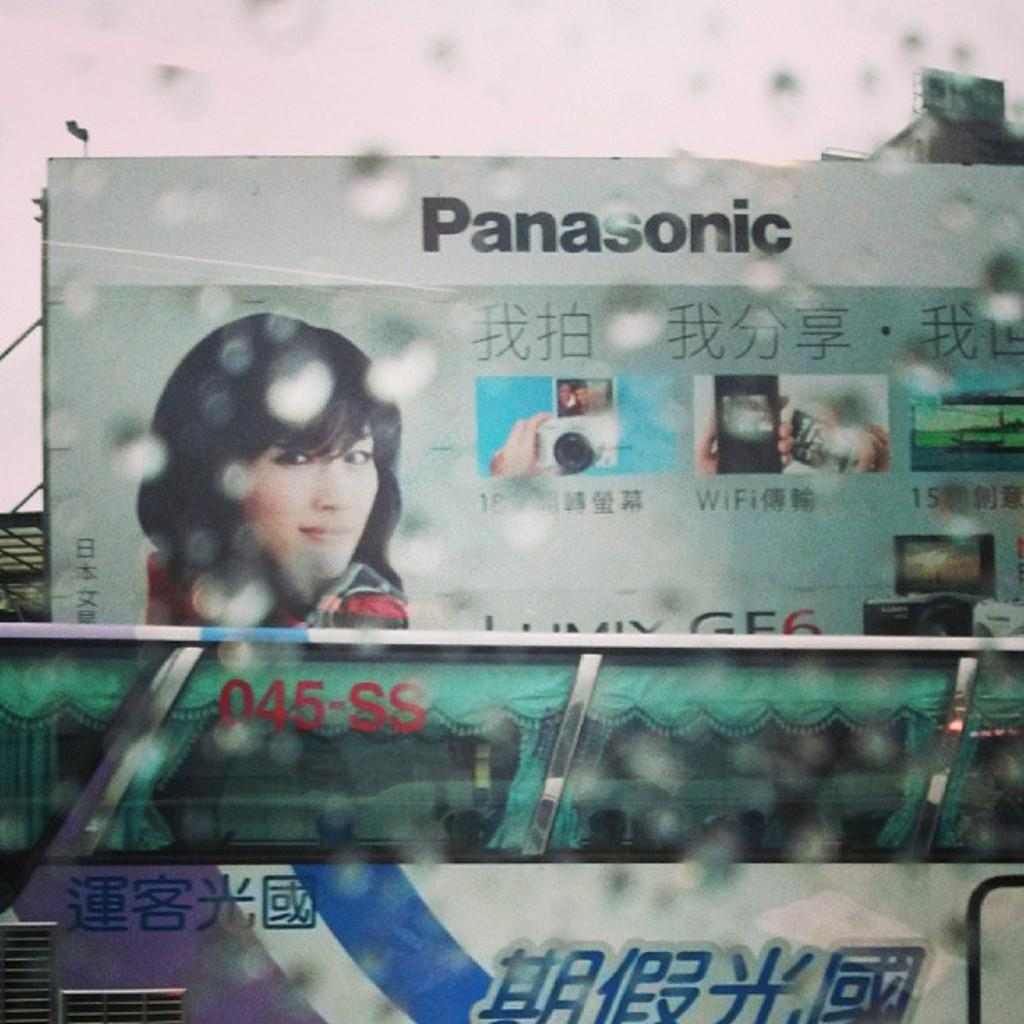What is the main subject in the middle of the image? There is a bus in the middle of the image. What can be seen behind the bus? There is a big hoarding behind the bus. What is depicted on the hoarding? The hoarding features a girl. What is visible at the top of the image? The sky is visible at the top of the image. How many times does the girl on the hoarding stretch in the image? There is no indication in the image that the girl on the hoarding is stretching or performing any actions. 